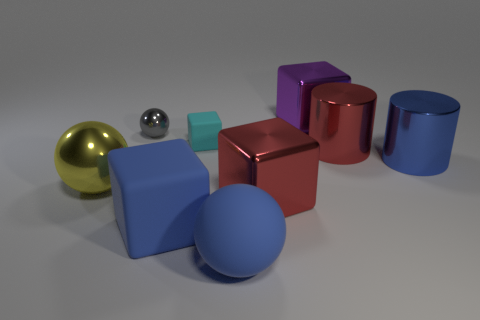How many large things are purple shiny blocks or red shiny things?
Offer a very short reply. 3. The tiny sphere has what color?
Offer a very short reply. Gray. Is there a big metallic block that is behind the big red object in front of the big blue cylinder?
Give a very brief answer. Yes. Are there fewer shiny objects on the left side of the blue metal cylinder than small spheres?
Give a very brief answer. No. Is the material of the large purple cube on the right side of the tiny gray metallic thing the same as the small cyan thing?
Offer a very short reply. No. There is a large sphere that is made of the same material as the cyan block; what color is it?
Provide a succinct answer. Blue. Is the number of gray spheres to the left of the yellow ball less than the number of cylinders to the left of the purple metal object?
Ensure brevity in your answer.  No. There is a big shiny object behind the tiny cyan matte cube; is it the same color as the matte block that is in front of the big yellow metal sphere?
Offer a very short reply. No. Are there any large blue things that have the same material as the large yellow object?
Provide a short and direct response. Yes. There is a metal object that is behind the gray metal ball that is in front of the purple metal object; what size is it?
Your response must be concise. Large. 